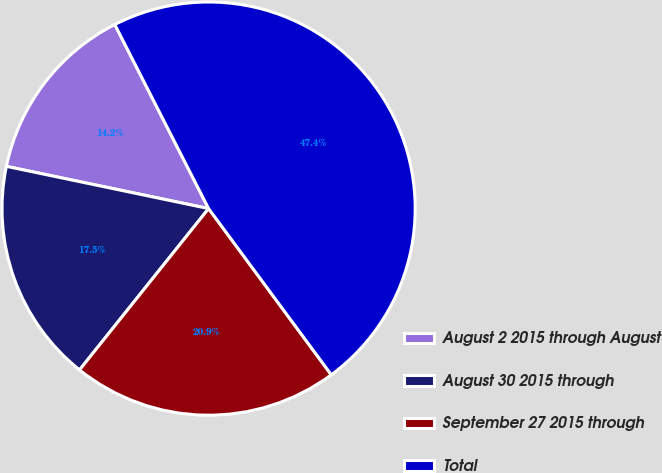Convert chart to OTSL. <chart><loc_0><loc_0><loc_500><loc_500><pie_chart><fcel>August 2 2015 through August<fcel>August 30 2015 through<fcel>September 27 2015 through<fcel>Total<nl><fcel>14.22%<fcel>17.54%<fcel>20.86%<fcel>47.38%<nl></chart> 